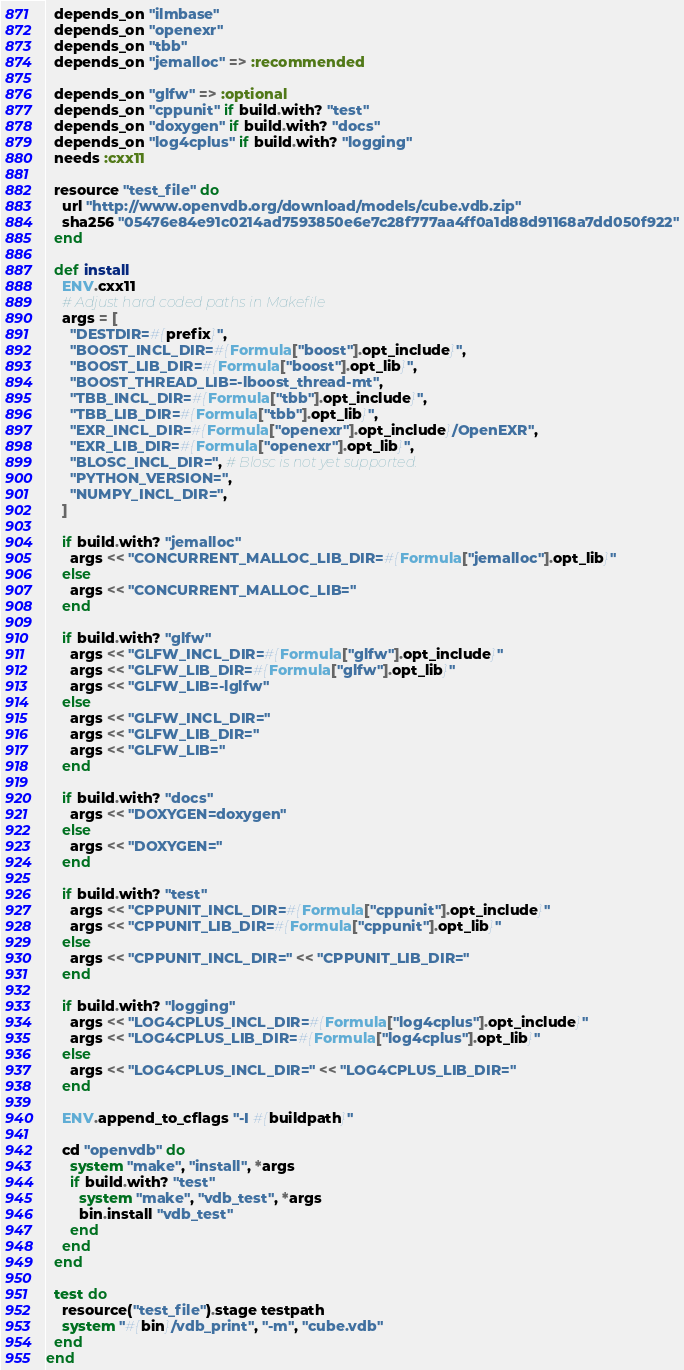Convert code to text. <code><loc_0><loc_0><loc_500><loc_500><_Ruby_>  depends_on "ilmbase"
  depends_on "openexr"
  depends_on "tbb"
  depends_on "jemalloc" => :recommended

  depends_on "glfw" => :optional
  depends_on "cppunit" if build.with? "test"
  depends_on "doxygen" if build.with? "docs"
  depends_on "log4cplus" if build.with? "logging"
  needs :cxx11

  resource "test_file" do
    url "http://www.openvdb.org/download/models/cube.vdb.zip"
    sha256 "05476e84e91c0214ad7593850e6e7c28f777aa4ff0a1d88d91168a7dd050f922"
  end

  def install
    ENV.cxx11
    # Adjust hard coded paths in Makefile
    args = [
      "DESTDIR=#{prefix}",
      "BOOST_INCL_DIR=#{Formula["boost"].opt_include}",
      "BOOST_LIB_DIR=#{Formula["boost"].opt_lib}",
      "BOOST_THREAD_LIB=-lboost_thread-mt",
      "TBB_INCL_DIR=#{Formula["tbb"].opt_include}",
      "TBB_LIB_DIR=#{Formula["tbb"].opt_lib}",
      "EXR_INCL_DIR=#{Formula["openexr"].opt_include}/OpenEXR",
      "EXR_LIB_DIR=#{Formula["openexr"].opt_lib}",
      "BLOSC_INCL_DIR=", # Blosc is not yet supported.
      "PYTHON_VERSION=",
      "NUMPY_INCL_DIR=",
    ]

    if build.with? "jemalloc"
      args << "CONCURRENT_MALLOC_LIB_DIR=#{Formula["jemalloc"].opt_lib}"
    else
      args << "CONCURRENT_MALLOC_LIB="
    end

    if build.with? "glfw"
      args << "GLFW_INCL_DIR=#{Formula["glfw"].opt_include}"
      args << "GLFW_LIB_DIR=#{Formula["glfw"].opt_lib}"
      args << "GLFW_LIB=-lglfw"
    else
      args << "GLFW_INCL_DIR="
      args << "GLFW_LIB_DIR="
      args << "GLFW_LIB="
    end

    if build.with? "docs"
      args << "DOXYGEN=doxygen"
    else
      args << "DOXYGEN="
    end

    if build.with? "test"
      args << "CPPUNIT_INCL_DIR=#{Formula["cppunit"].opt_include}"
      args << "CPPUNIT_LIB_DIR=#{Formula["cppunit"].opt_lib}"
    else
      args << "CPPUNIT_INCL_DIR=" << "CPPUNIT_LIB_DIR="
    end

    if build.with? "logging"
      args << "LOG4CPLUS_INCL_DIR=#{Formula["log4cplus"].opt_include}"
      args << "LOG4CPLUS_LIB_DIR=#{Formula["log4cplus"].opt_lib}"
    else
      args << "LOG4CPLUS_INCL_DIR=" << "LOG4CPLUS_LIB_DIR="
    end

    ENV.append_to_cflags "-I #{buildpath}"

    cd "openvdb" do
      system "make", "install", *args
      if build.with? "test"
        system "make", "vdb_test", *args
        bin.install "vdb_test"
      end
    end
  end

  test do
    resource("test_file").stage testpath
    system "#{bin}/vdb_print", "-m", "cube.vdb"
  end
end
</code> 